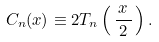<formula> <loc_0><loc_0><loc_500><loc_500>C _ { n } ( x ) \equiv 2 T _ { n } \left ( \, { \frac { \, x \, } { 2 } } \, \right ) .</formula> 